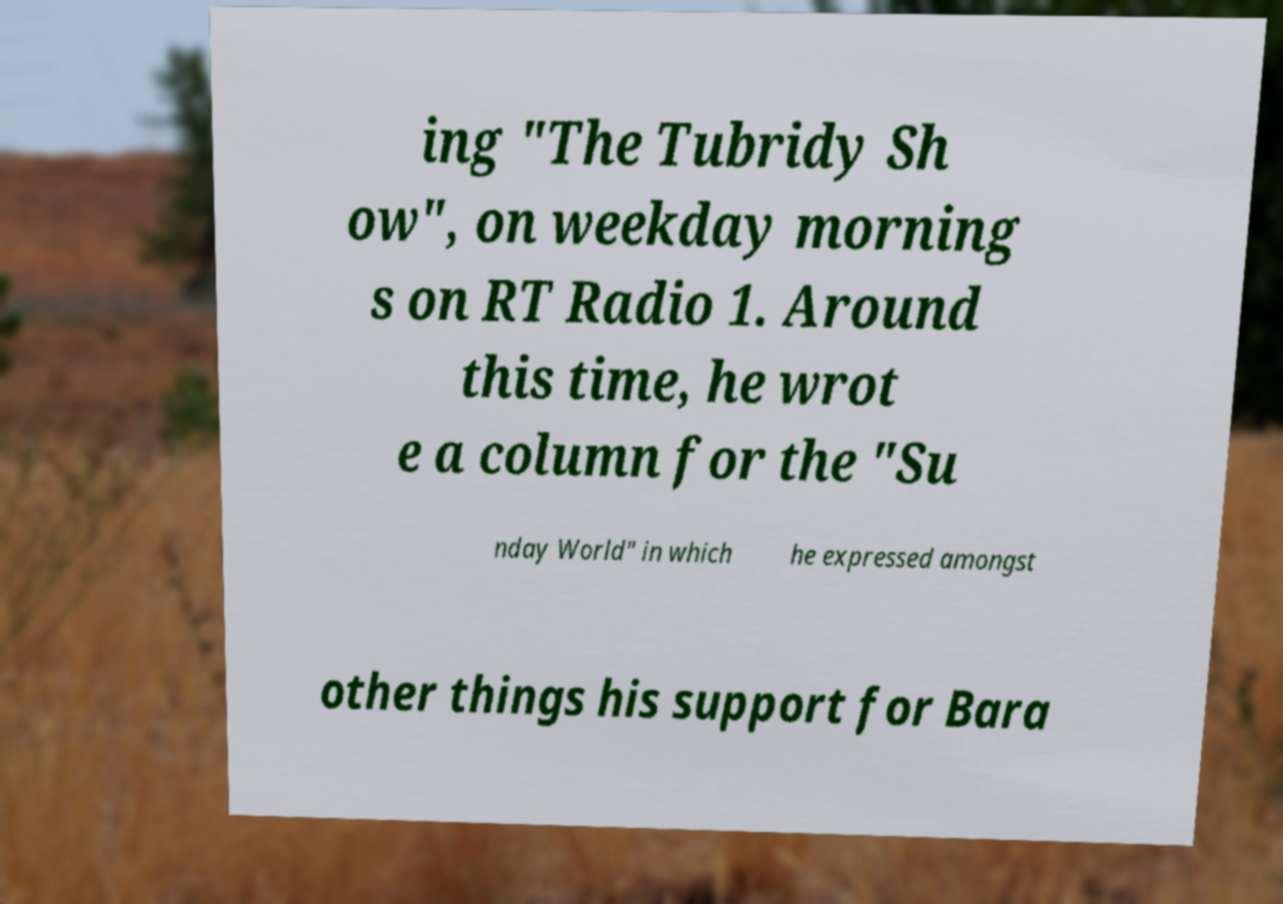I need the written content from this picture converted into text. Can you do that? ing "The Tubridy Sh ow", on weekday morning s on RT Radio 1. Around this time, he wrot e a column for the "Su nday World" in which he expressed amongst other things his support for Bara 